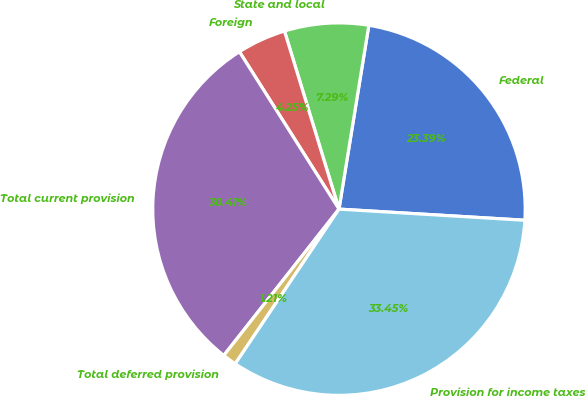<chart> <loc_0><loc_0><loc_500><loc_500><pie_chart><fcel>Federal<fcel>State and local<fcel>Foreign<fcel>Total current provision<fcel>Total deferred provision<fcel>Provision for income taxes<nl><fcel>23.39%<fcel>7.29%<fcel>4.25%<fcel>30.41%<fcel>1.21%<fcel>33.45%<nl></chart> 